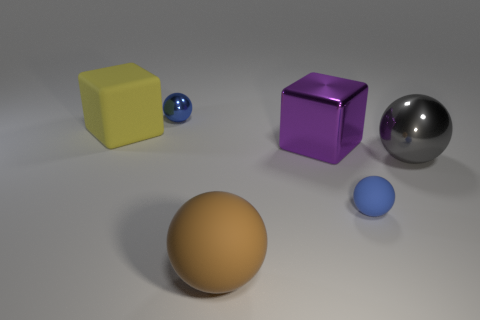Subtract all tiny rubber spheres. How many spheres are left? 3 Add 3 large cyan shiny cylinders. How many objects exist? 9 Subtract all yellow cubes. How many cubes are left? 1 Subtract all blue blocks. How many blue balls are left? 2 Subtract all blocks. How many objects are left? 4 Subtract 1 cubes. How many cubes are left? 1 Subtract 0 green spheres. How many objects are left? 6 Subtract all cyan blocks. Subtract all green cylinders. How many blocks are left? 2 Subtract all blue metal objects. Subtract all large yellow rubber cubes. How many objects are left? 4 Add 6 small blue shiny objects. How many small blue shiny objects are left? 7 